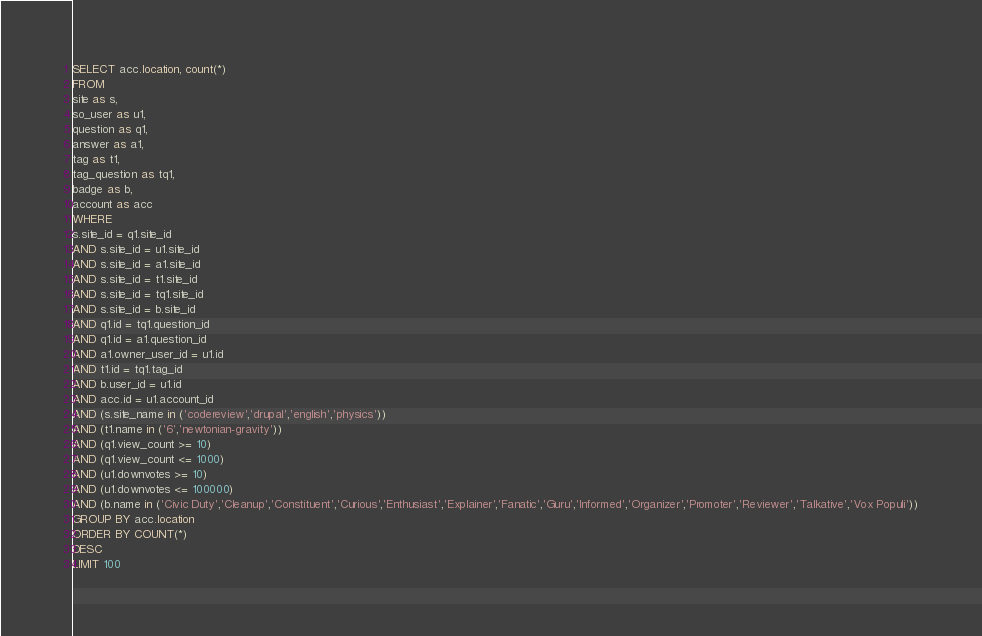<code> <loc_0><loc_0><loc_500><loc_500><_SQL_>SELECT acc.location, count(*)
FROM
site as s,
so_user as u1,
question as q1,
answer as a1,
tag as t1,
tag_question as tq1,
badge as b,
account as acc
WHERE
s.site_id = q1.site_id
AND s.site_id = u1.site_id
AND s.site_id = a1.site_id
AND s.site_id = t1.site_id
AND s.site_id = tq1.site_id
AND s.site_id = b.site_id
AND q1.id = tq1.question_id
AND q1.id = a1.question_id
AND a1.owner_user_id = u1.id
AND t1.id = tq1.tag_id
AND b.user_id = u1.id
AND acc.id = u1.account_id
AND (s.site_name in ('codereview','drupal','english','physics'))
AND (t1.name in ('6','newtonian-gravity'))
AND (q1.view_count >= 10)
AND (q1.view_count <= 1000)
AND (u1.downvotes >= 10)
AND (u1.downvotes <= 100000)
AND (b.name in ('Civic Duty','Cleanup','Constituent','Curious','Enthusiast','Explainer','Fanatic','Guru','Informed','Organizer','Promoter','Reviewer','Talkative','Vox Populi'))
GROUP BY acc.location
ORDER BY COUNT(*)
DESC
LIMIT 100
</code> 